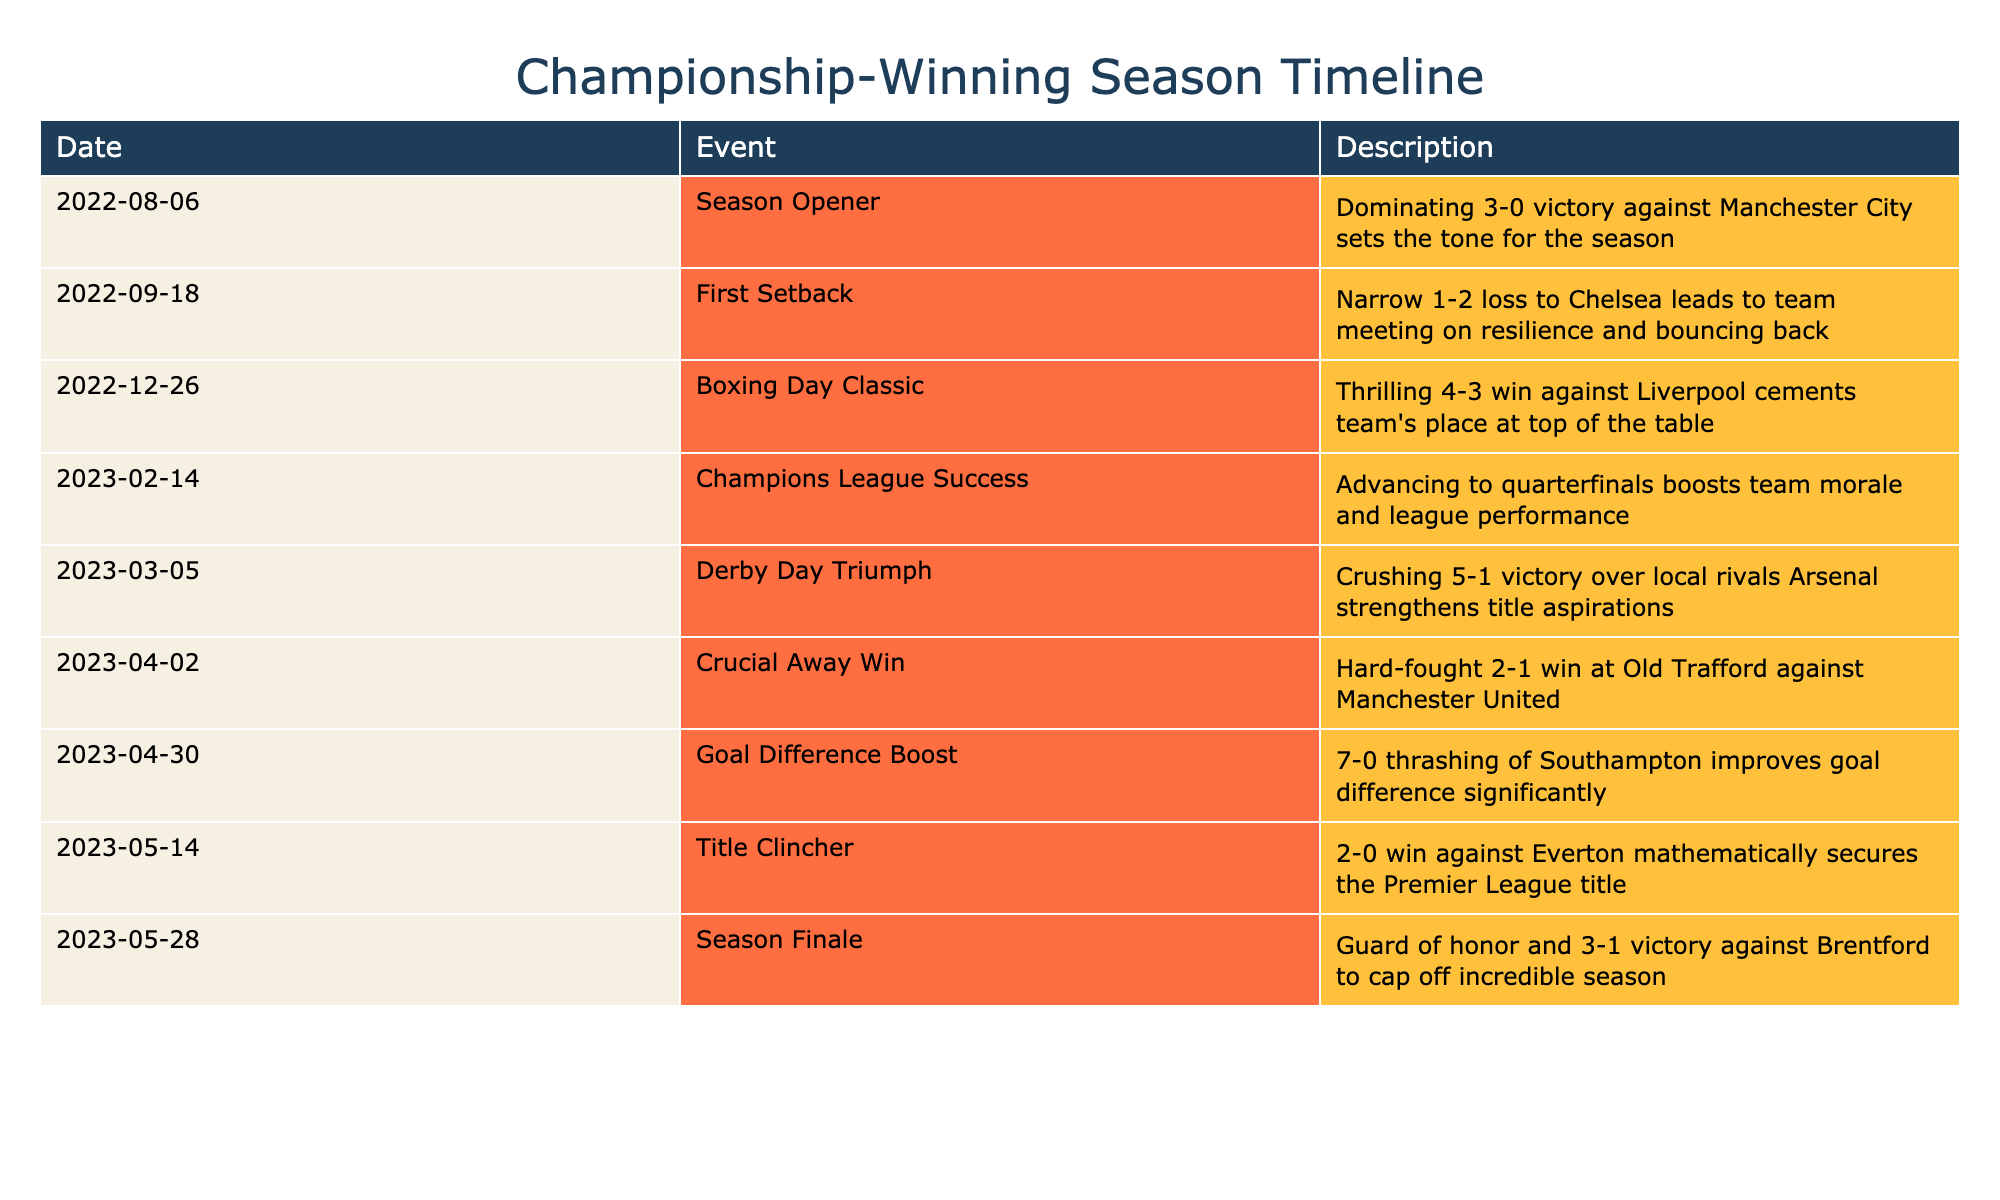What event marked the beginning of the championship-winning season? The table shows that the season opener on August 6, 2022, was a dominating 3-0 victory against Manchester City. This event is the first row in the table, indicating it marks the start of the season.
Answer: 3-0 victory against Manchester City How many matches listed in the table resulted in a win? By examining each event in the table, we can count the wins. The events with wins are: the season opener, Boxing Day Classic, Derby Day Triumph, crucial away win, goal difference boost, title clincher, and season finale. This totals to 7 wins.
Answer: 7 Was there a match where the team lost? The table indicates the first setback on September 18, 2022, which was a narrow 1-2 loss to Chelsea. Hence, there is indeed a recorded loss during the season.
Answer: Yes What was the goal difference in the match against Southampton? From the event on April 30, 2023, we see that the team won by a score of 7-0 against Southampton. The goal difference is calculated by subtracting the goals conceded from goals scored, which is 7 - 0 = 7.
Answer: 7 What is the total number of events occurring in 2023? To find this, we can count the events listed under the year 2023, which are from February 14 onwards. Specifically, there are four events (Champions League Success, Derby Day Triumph, Crucial Away Win, Goal Difference Boost, Title Clincher, and Season Finale).
Answer: 6 What was the outcome of the Boxing Day Classic? The table shows that in the Boxing Day Classic on December 26, 2022, there was a thrilling 4-3 win against Liverpool. Therefore, the outcome was a win.
Answer: Win Did the team have any setbacks after the season opener? By looking at the table, we see the first setback was a loss to Chelsea after the season opener. This indicates there was a setback following the opening match.
Answer: Yes What was the significance of the match against Everton on May 14, 2023? The table specifies that this match was a 2-0 win against Everton, which mathematically secured the Premier League title for the team. Thus, this match was crucial for title confirmation.
Answer: Mathematically secured the Premier League title 